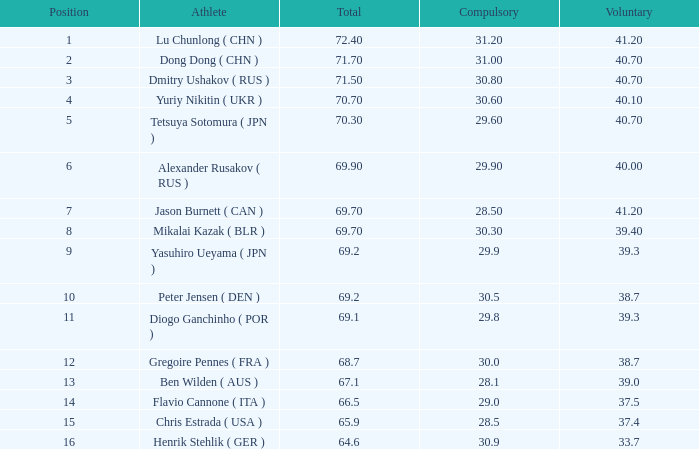What's the total of the position of 1? None. 